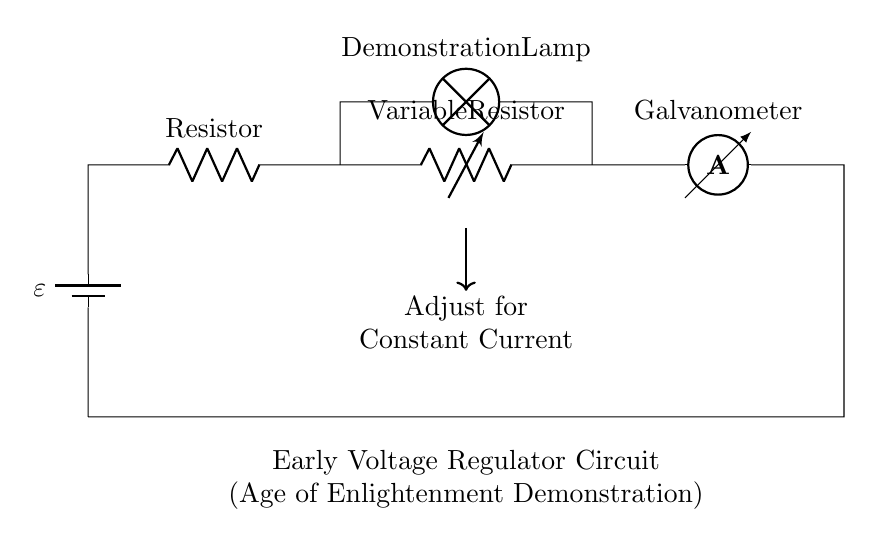What is the purpose of the variable resistor in this circuit? The variable resistor functions as an adjustable component that allows the user to change the resistance in order to regulate the current flowing through the circuit. This control is essential for maintaining a constant current across the load (lamp) under varying conditions.
Answer: adjustable component What type of current is monitored in this circuit? The ammeter is used to monitor the current flowing in the circuit, specifically measuring the direct current supplied to the lamp. This helps in ensuring the current stays at a desired level.
Answer: direct current What component is used to provide voltage in this circuit? The battery is the component providing voltage, denoted by ε. It creates an electric potential difference necessary for driving current through the circuit.
Answer: battery How is the current adjusted in this demonstration circuit? The current is adjusted by modifying the resistance of the variable resistor. By increasing or decreasing its resistance, the current can be controlled to maintain a steady flow to the lamp.
Answer: modifying resistance What is the role of the lamp in this circuit? The lamp acts as a load that demonstrates the effect of voltage and current in the circuit, visually indicating the flow of electricity when powered.
Answer: load demonstration What is indicated by the arrow pointing from the variable resistor to the label "Adjust for Constant Current"? The arrow indicates that the variable resistor should be manipulated to set the current to a constant level, showing users how to achieve stable conditions in the circuit.
Answer: set constant current 